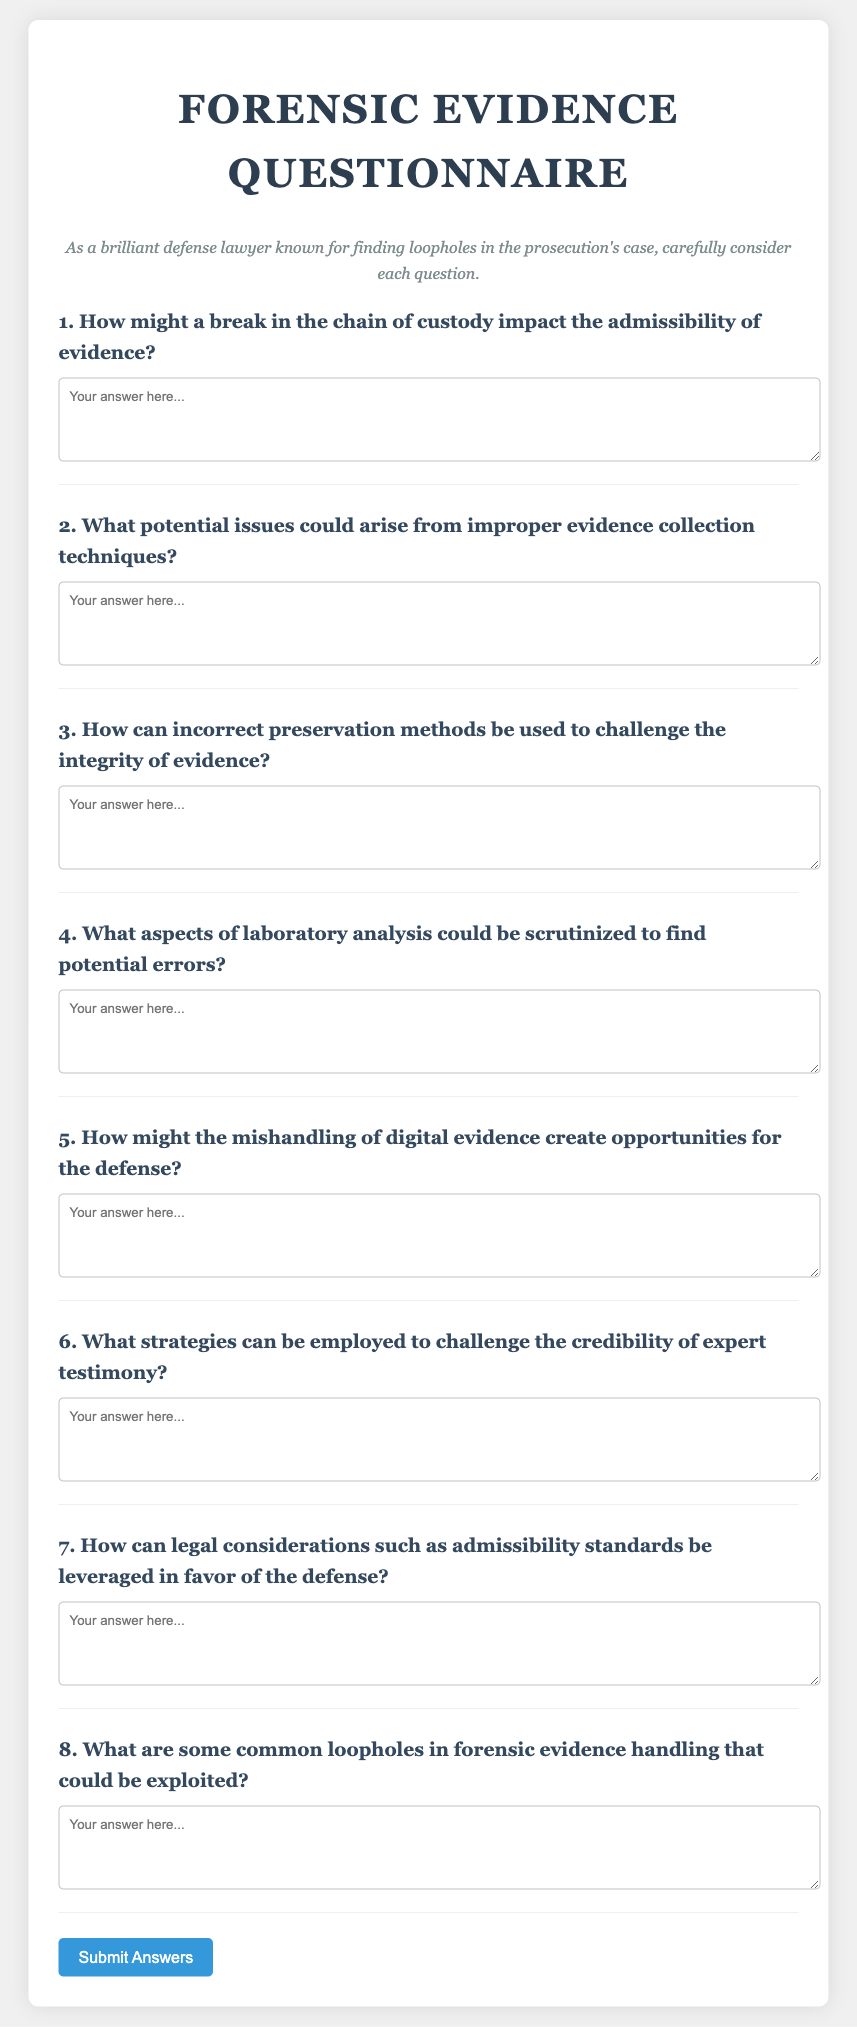What is the title of the document? The title is displayed in the header of the document and describes its content.
Answer: Forensic Evidence Questionnaire How many main questions are included in the questionnaire? The number of main questions can be counted from the structure of the document.
Answer: Eight What is the suggested character for the font used in the document? The font details are provided in the styling section of the code.
Answer: Georgia What color is the background of the document? The background color is specified in the CSS styling section of the document.
Answer: #f0f0f0 What function is triggered when the submit button is clicked? The function associated with the button is indicated in the onclick attribute.
Answer: alert('Responses submitted!') What type of questions are included in the questionnaire? The overall nature and purpose of the questions are indicated by the document section title.
Answer: Short-answer questions What is the color of the button when hovered over? The hover effect color is stated in the CSS styling for the button.
Answer: #2980b9 What is the maximum width specified for the document? This can be found in the CSS styles for the main container.
Answer: 800px 